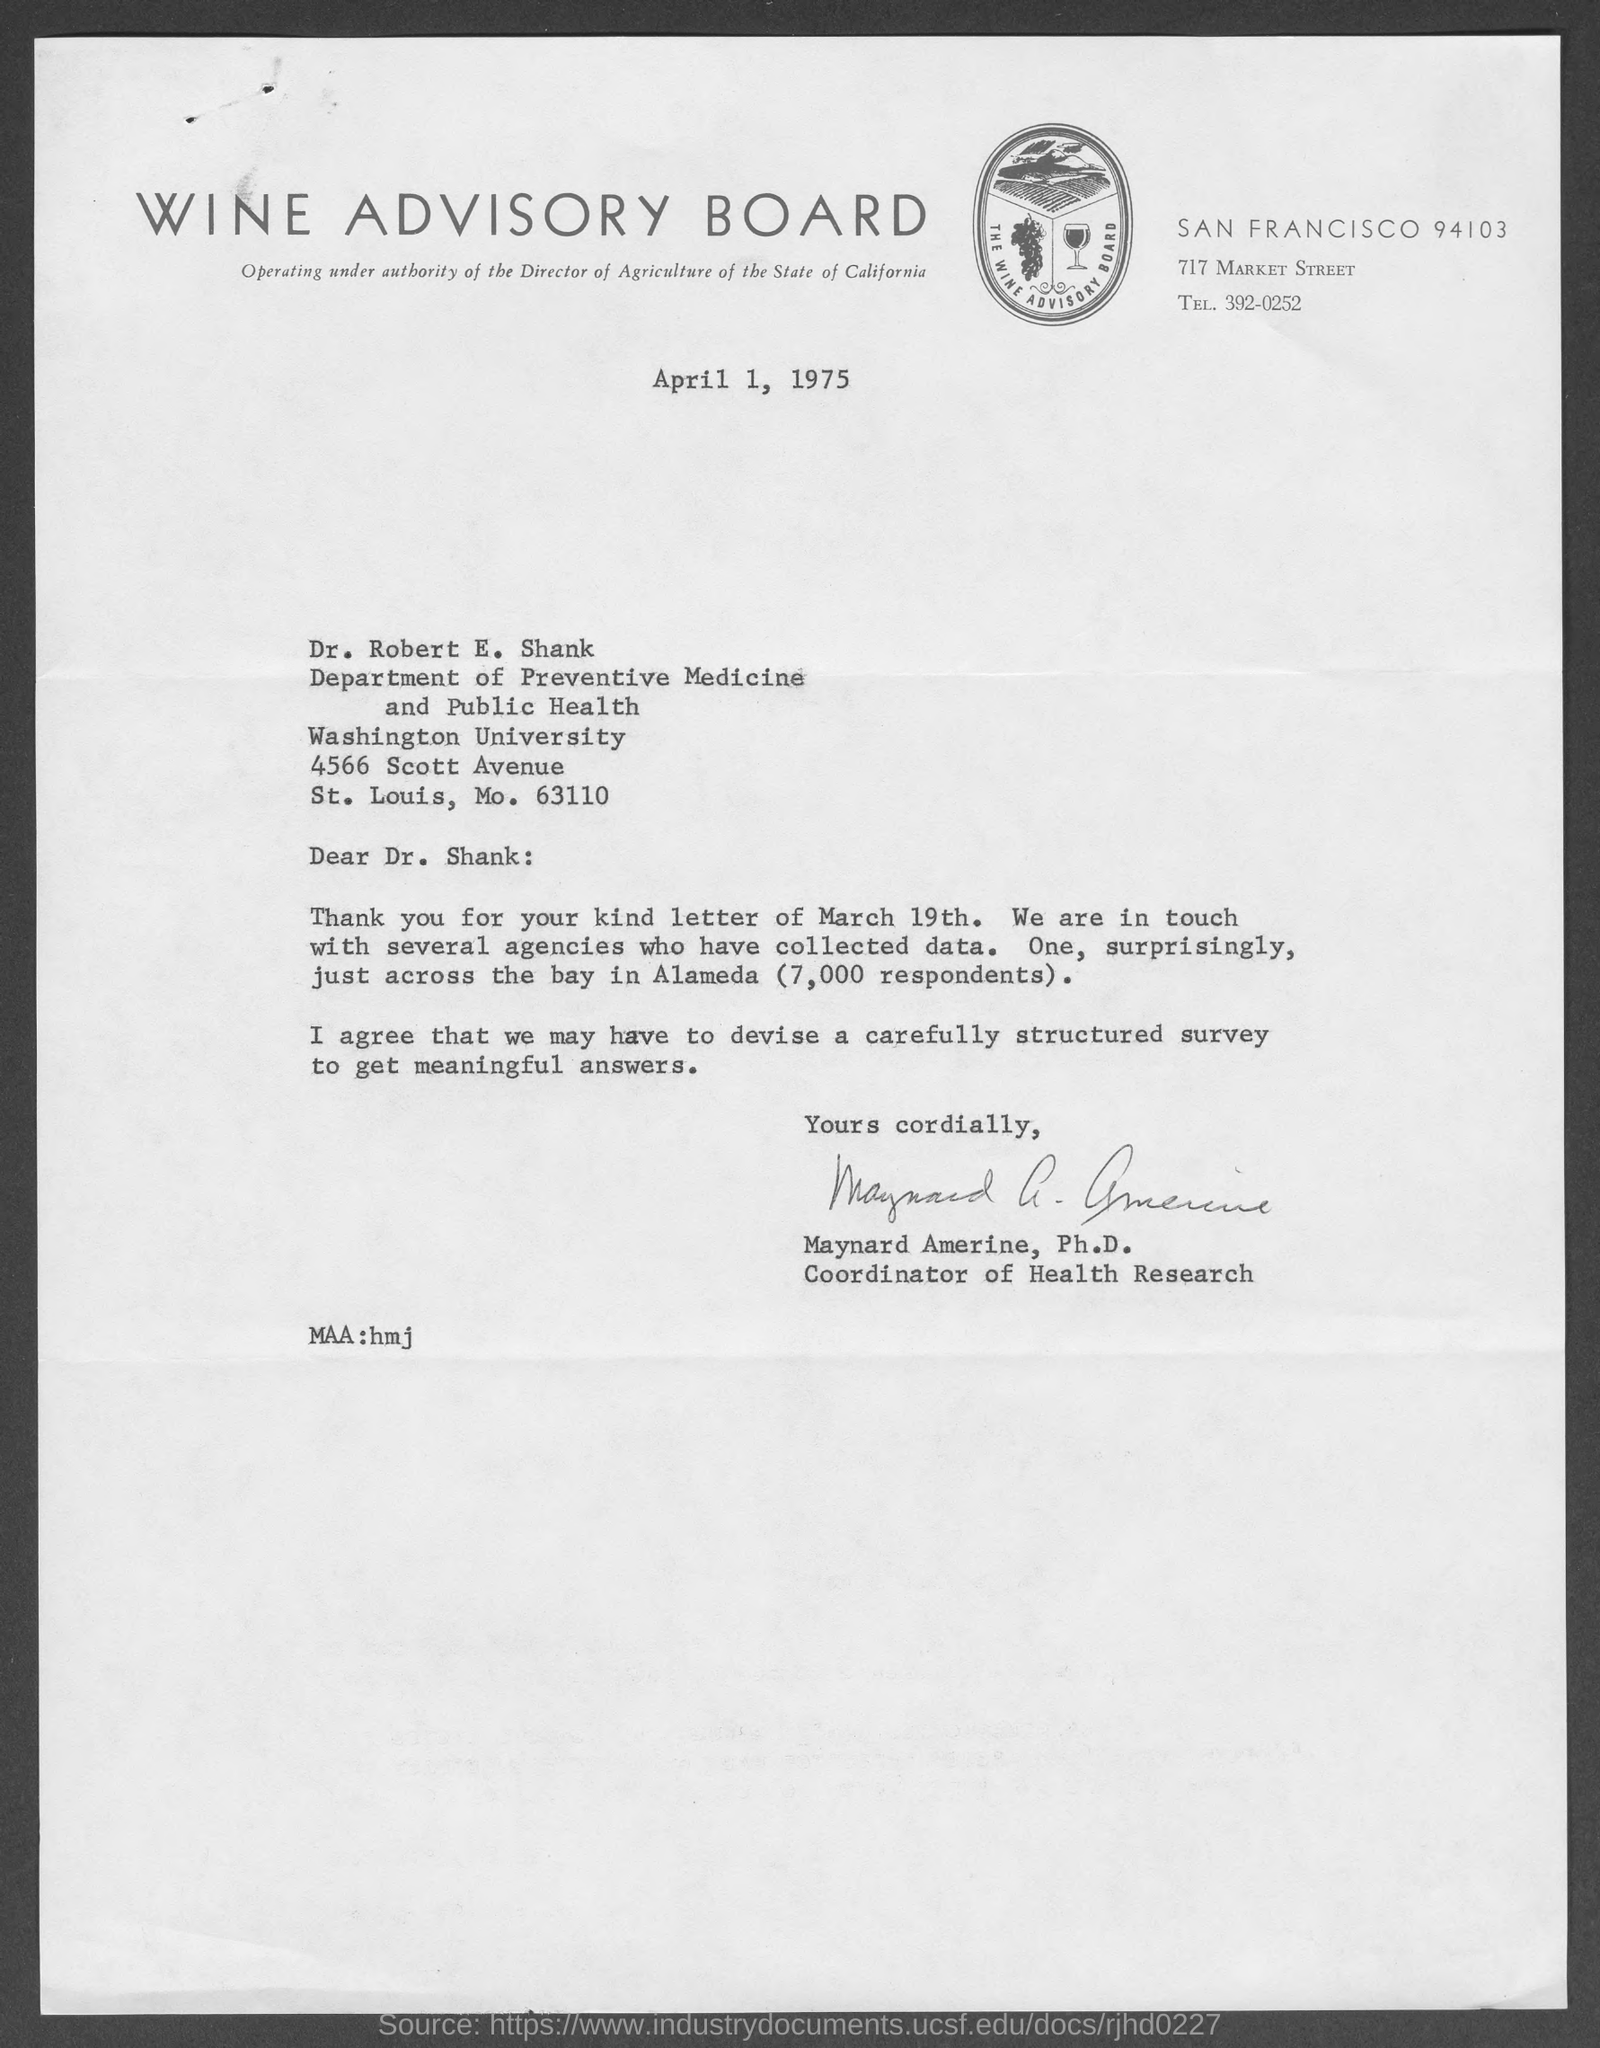Which company is mentioned in the letterhead?
Provide a succinct answer. WINE ADVISORY BOARD. Who is the sender of this letter?
Your response must be concise. Maynard Amerine, Ph.D. What is the designation of Maynard Amerine, Ph.D.?
Offer a very short reply. Coordinator of Health Research. 